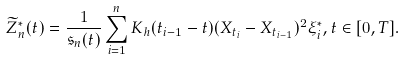Convert formula to latex. <formula><loc_0><loc_0><loc_500><loc_500>\widetilde { Z } _ { n } ^ { * } ( t ) = \frac { 1 } { \mathfrak { s } _ { n } ( t ) } \sum _ { i = 1 } ^ { n } K _ { h } ( t _ { i - 1 } - t ) ( X _ { t _ { i } } - X _ { t _ { i - 1 } } ) ^ { 2 } \xi _ { i } ^ { * } , t \in [ 0 , T ] .</formula> 